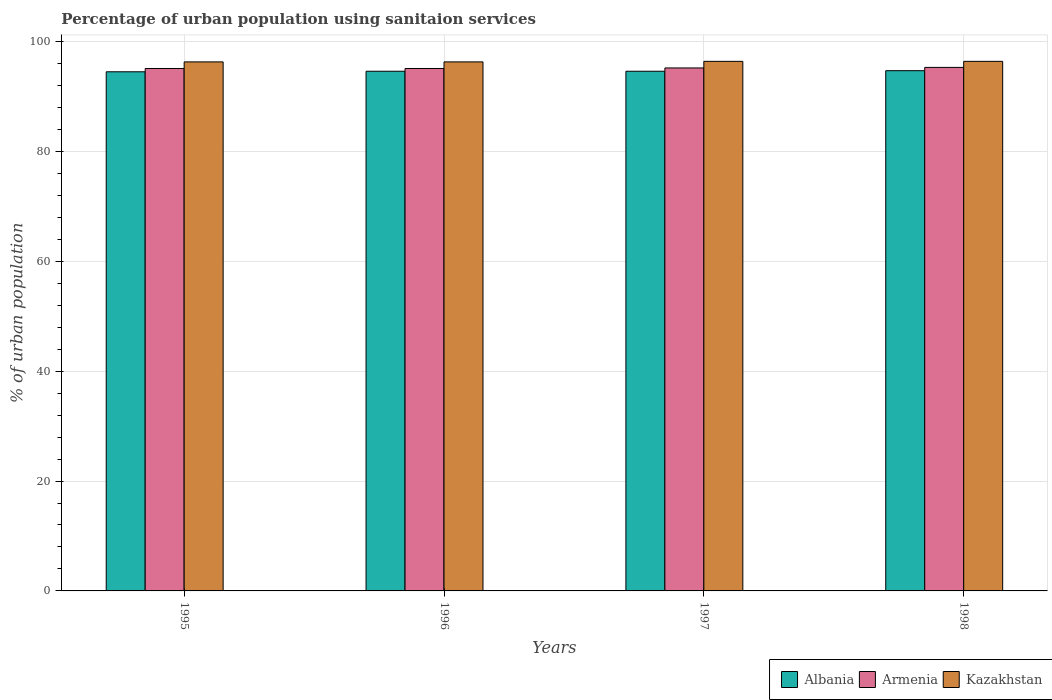How many different coloured bars are there?
Make the answer very short. 3. How many groups of bars are there?
Your answer should be compact. 4. How many bars are there on the 4th tick from the left?
Give a very brief answer. 3. In how many cases, is the number of bars for a given year not equal to the number of legend labels?
Make the answer very short. 0. What is the percentage of urban population using sanitaion services in Armenia in 1997?
Give a very brief answer. 95.2. Across all years, what is the maximum percentage of urban population using sanitaion services in Armenia?
Offer a terse response. 95.3. Across all years, what is the minimum percentage of urban population using sanitaion services in Armenia?
Give a very brief answer. 95.1. In which year was the percentage of urban population using sanitaion services in Kazakhstan maximum?
Your answer should be very brief. 1997. In which year was the percentage of urban population using sanitaion services in Kazakhstan minimum?
Ensure brevity in your answer.  1995. What is the total percentage of urban population using sanitaion services in Armenia in the graph?
Provide a short and direct response. 380.7. What is the difference between the percentage of urban population using sanitaion services in Albania in 1997 and that in 1998?
Offer a very short reply. -0.1. What is the average percentage of urban population using sanitaion services in Albania per year?
Your answer should be very brief. 94.6. In the year 1997, what is the difference between the percentage of urban population using sanitaion services in Kazakhstan and percentage of urban population using sanitaion services in Albania?
Make the answer very short. 1.8. What is the ratio of the percentage of urban population using sanitaion services in Armenia in 1996 to that in 1998?
Your response must be concise. 1. What is the difference between the highest and the second highest percentage of urban population using sanitaion services in Albania?
Offer a very short reply. 0.1. What is the difference between the highest and the lowest percentage of urban population using sanitaion services in Armenia?
Ensure brevity in your answer.  0.2. Is the sum of the percentage of urban population using sanitaion services in Albania in 1995 and 1997 greater than the maximum percentage of urban population using sanitaion services in Kazakhstan across all years?
Provide a succinct answer. Yes. What does the 1st bar from the left in 1995 represents?
Keep it short and to the point. Albania. What does the 1st bar from the right in 1998 represents?
Ensure brevity in your answer.  Kazakhstan. Is it the case that in every year, the sum of the percentage of urban population using sanitaion services in Albania and percentage of urban population using sanitaion services in Kazakhstan is greater than the percentage of urban population using sanitaion services in Armenia?
Keep it short and to the point. Yes. How many bars are there?
Your answer should be compact. 12. Are all the bars in the graph horizontal?
Keep it short and to the point. No. How many years are there in the graph?
Keep it short and to the point. 4. How many legend labels are there?
Provide a short and direct response. 3. How are the legend labels stacked?
Give a very brief answer. Horizontal. What is the title of the graph?
Your response must be concise. Percentage of urban population using sanitaion services. Does "Cabo Verde" appear as one of the legend labels in the graph?
Make the answer very short. No. What is the label or title of the X-axis?
Offer a very short reply. Years. What is the label or title of the Y-axis?
Offer a very short reply. % of urban population. What is the % of urban population in Albania in 1995?
Keep it short and to the point. 94.5. What is the % of urban population of Armenia in 1995?
Make the answer very short. 95.1. What is the % of urban population in Kazakhstan in 1995?
Offer a terse response. 96.3. What is the % of urban population in Albania in 1996?
Your answer should be compact. 94.6. What is the % of urban population of Armenia in 1996?
Offer a very short reply. 95.1. What is the % of urban population in Kazakhstan in 1996?
Your answer should be compact. 96.3. What is the % of urban population in Albania in 1997?
Offer a very short reply. 94.6. What is the % of urban population in Armenia in 1997?
Provide a succinct answer. 95.2. What is the % of urban population of Kazakhstan in 1997?
Offer a terse response. 96.4. What is the % of urban population of Albania in 1998?
Ensure brevity in your answer.  94.7. What is the % of urban population in Armenia in 1998?
Keep it short and to the point. 95.3. What is the % of urban population of Kazakhstan in 1998?
Ensure brevity in your answer.  96.4. Across all years, what is the maximum % of urban population of Albania?
Your response must be concise. 94.7. Across all years, what is the maximum % of urban population in Armenia?
Keep it short and to the point. 95.3. Across all years, what is the maximum % of urban population in Kazakhstan?
Offer a very short reply. 96.4. Across all years, what is the minimum % of urban population of Albania?
Provide a short and direct response. 94.5. Across all years, what is the minimum % of urban population in Armenia?
Your answer should be very brief. 95.1. Across all years, what is the minimum % of urban population in Kazakhstan?
Keep it short and to the point. 96.3. What is the total % of urban population of Albania in the graph?
Your answer should be compact. 378.4. What is the total % of urban population in Armenia in the graph?
Offer a terse response. 380.7. What is the total % of urban population of Kazakhstan in the graph?
Your answer should be compact. 385.4. What is the difference between the % of urban population in Albania in 1995 and that in 1996?
Offer a terse response. -0.1. What is the difference between the % of urban population in Albania in 1995 and that in 1997?
Give a very brief answer. -0.1. What is the difference between the % of urban population in Albania in 1995 and that in 1998?
Provide a succinct answer. -0.2. What is the difference between the % of urban population of Armenia in 1995 and that in 1998?
Keep it short and to the point. -0.2. What is the difference between the % of urban population of Albania in 1996 and that in 1997?
Make the answer very short. 0. What is the difference between the % of urban population in Armenia in 1996 and that in 1997?
Give a very brief answer. -0.1. What is the difference between the % of urban population of Albania in 1996 and that in 1998?
Provide a succinct answer. -0.1. What is the difference between the % of urban population in Albania in 1997 and that in 1998?
Your response must be concise. -0.1. What is the difference between the % of urban population of Kazakhstan in 1997 and that in 1998?
Your response must be concise. 0. What is the difference between the % of urban population of Albania in 1995 and the % of urban population of Armenia in 1997?
Give a very brief answer. -0.7. What is the difference between the % of urban population in Albania in 1995 and the % of urban population in Kazakhstan in 1997?
Your answer should be compact. -1.9. What is the difference between the % of urban population of Albania in 1995 and the % of urban population of Armenia in 1998?
Make the answer very short. -0.8. What is the difference between the % of urban population of Albania in 1995 and the % of urban population of Kazakhstan in 1998?
Ensure brevity in your answer.  -1.9. What is the difference between the % of urban population in Albania in 1996 and the % of urban population in Kazakhstan in 1997?
Your response must be concise. -1.8. What is the difference between the % of urban population of Armenia in 1996 and the % of urban population of Kazakhstan in 1997?
Give a very brief answer. -1.3. What is the difference between the % of urban population in Armenia in 1996 and the % of urban population in Kazakhstan in 1998?
Provide a short and direct response. -1.3. What is the difference between the % of urban population in Albania in 1997 and the % of urban population in Kazakhstan in 1998?
Make the answer very short. -1.8. What is the average % of urban population of Albania per year?
Your answer should be compact. 94.6. What is the average % of urban population in Armenia per year?
Keep it short and to the point. 95.17. What is the average % of urban population of Kazakhstan per year?
Provide a succinct answer. 96.35. In the year 1996, what is the difference between the % of urban population in Albania and % of urban population in Armenia?
Your answer should be compact. -0.5. In the year 1996, what is the difference between the % of urban population in Albania and % of urban population in Kazakhstan?
Ensure brevity in your answer.  -1.7. In the year 1996, what is the difference between the % of urban population of Armenia and % of urban population of Kazakhstan?
Provide a short and direct response. -1.2. In the year 1997, what is the difference between the % of urban population in Albania and % of urban population in Armenia?
Keep it short and to the point. -0.6. In the year 1998, what is the difference between the % of urban population of Albania and % of urban population of Armenia?
Give a very brief answer. -0.6. In the year 1998, what is the difference between the % of urban population of Armenia and % of urban population of Kazakhstan?
Make the answer very short. -1.1. What is the ratio of the % of urban population of Albania in 1995 to that in 1996?
Your answer should be very brief. 1. What is the ratio of the % of urban population of Albania in 1995 to that in 1997?
Ensure brevity in your answer.  1. What is the ratio of the % of urban population of Armenia in 1995 to that in 1998?
Your response must be concise. 1. What is the ratio of the % of urban population of Kazakhstan in 1995 to that in 1998?
Keep it short and to the point. 1. What is the ratio of the % of urban population of Albania in 1996 to that in 1997?
Keep it short and to the point. 1. What is the ratio of the % of urban population in Kazakhstan in 1996 to that in 1997?
Keep it short and to the point. 1. What is the ratio of the % of urban population in Albania in 1996 to that in 1998?
Your response must be concise. 1. What is the ratio of the % of urban population of Armenia in 1996 to that in 1998?
Ensure brevity in your answer.  1. What is the ratio of the % of urban population of Kazakhstan in 1996 to that in 1998?
Provide a succinct answer. 1. What is the ratio of the % of urban population in Albania in 1997 to that in 1998?
Your response must be concise. 1. What is the ratio of the % of urban population of Kazakhstan in 1997 to that in 1998?
Keep it short and to the point. 1. What is the difference between the highest and the second highest % of urban population of Armenia?
Your response must be concise. 0.1. 